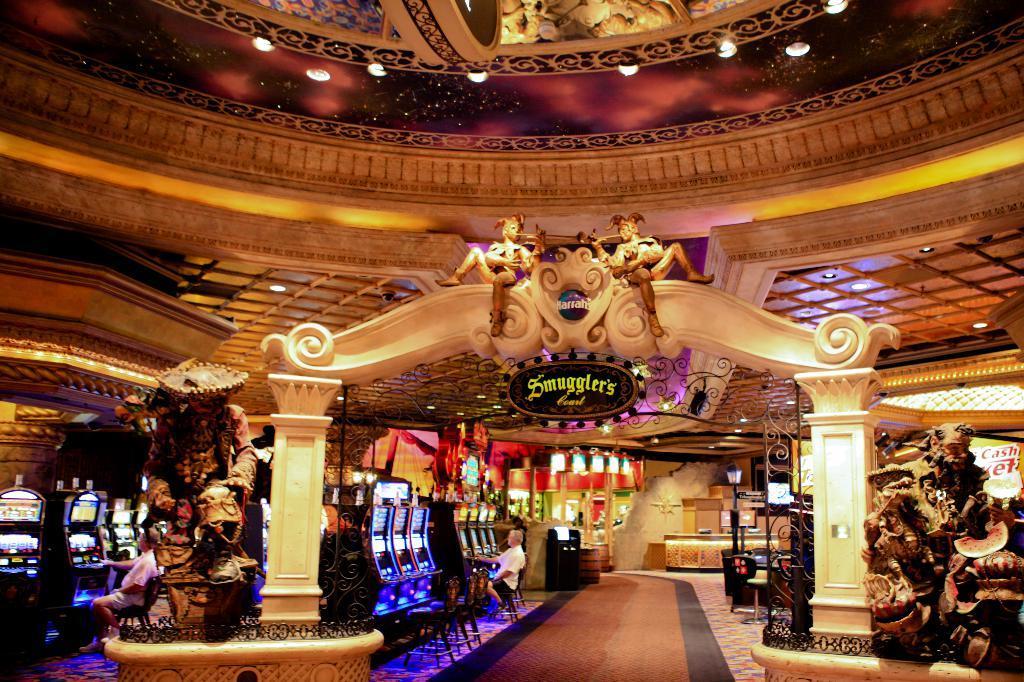In one or two sentences, can you explain what this image depicts? In this image we can see an arch with some statues and a signboard. On the backside we can see some statues, tables, lights, a lamp and some people sitting on the chairs in front of the slot machines. On the backside we can see a wall and a roof with some ceiling lights. 